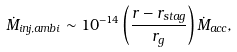<formula> <loc_0><loc_0><loc_500><loc_500>\dot { M } _ { i n j , a m b i } \sim 1 0 ^ { - 1 4 } \left ( \frac { r - r _ { s t a g } } { r _ { g } } \right ) \dot { M } _ { a c c } ,</formula> 